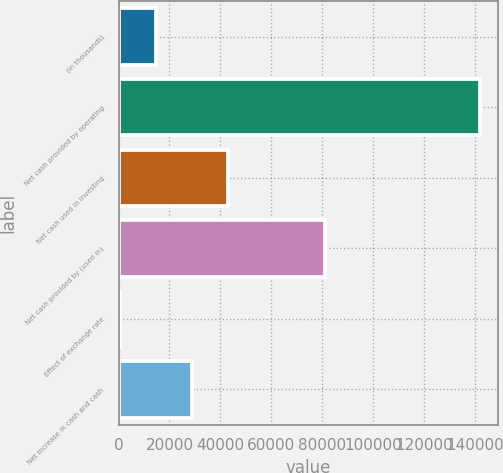Convert chart to OTSL. <chart><loc_0><loc_0><loc_500><loc_500><bar_chart><fcel>(in thousands)<fcel>Net cash provided by operating<fcel>Net cash used in investing<fcel>Net cash provided by (used in)<fcel>Effect of exchange rate<fcel>Net increase in cash and cash<nl><fcel>14704.9<fcel>141919<fcel>42974.7<fcel>80989<fcel>570<fcel>28839.8<nl></chart> 